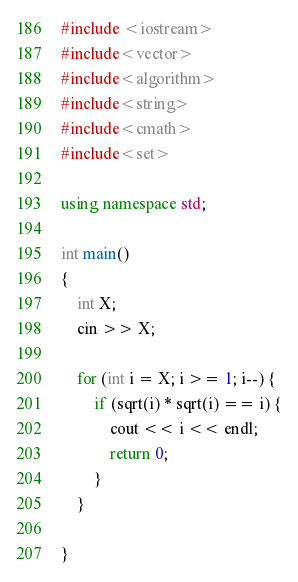Convert code to text. <code><loc_0><loc_0><loc_500><loc_500><_C++_>#include <iostream>
#include<vector>
#include<algorithm>
#include<string>
#include<cmath>
#include<set>

using namespace std;

int main()
{
	int X;
	cin >> X;

	for (int i = X; i >= 1; i--) {
		if (sqrt(i) * sqrt(i) == i) {
			cout << i << endl;
			return 0;
		}
	}
	
}




</code> 